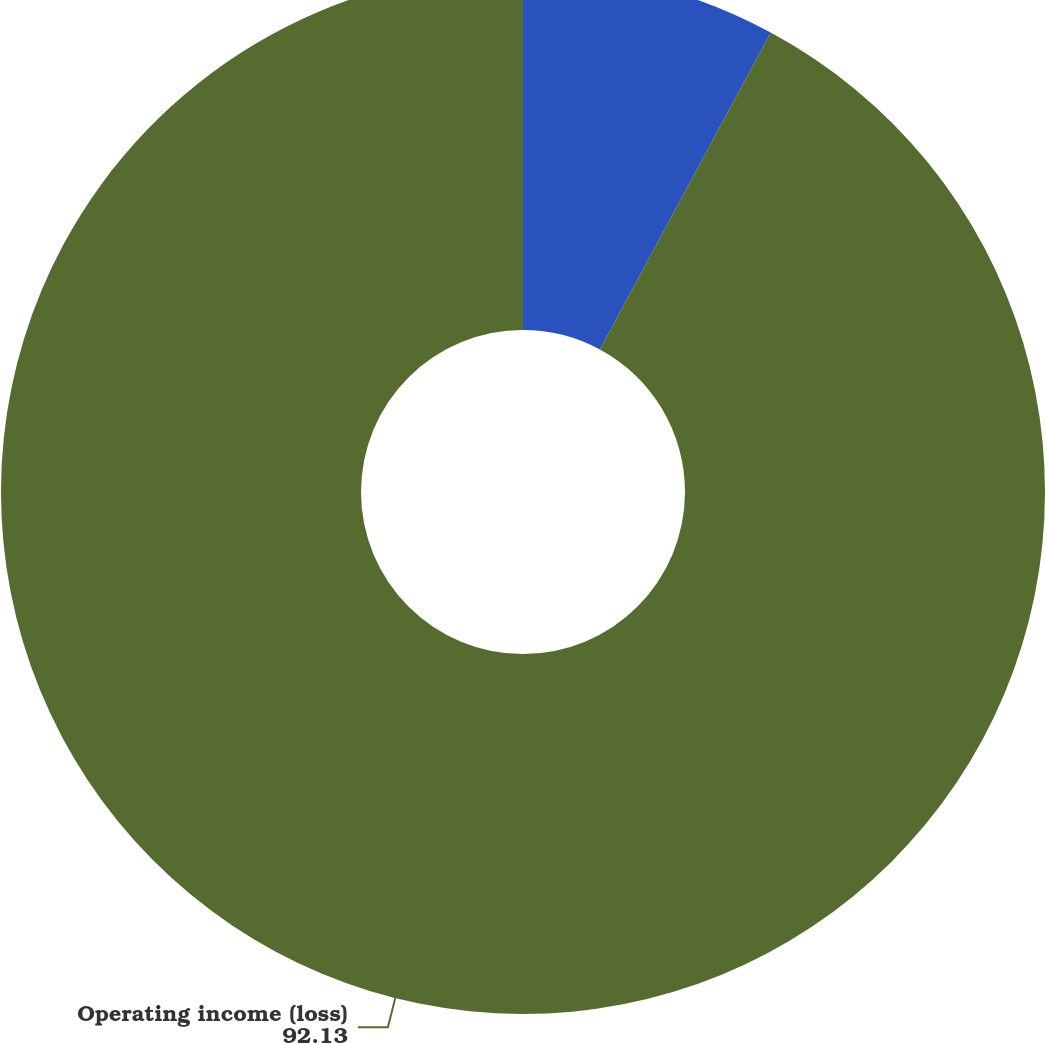Convert chart. <chart><loc_0><loc_0><loc_500><loc_500><pie_chart><fcel>Revenues<fcel>Operating income (loss)<nl><fcel>7.87%<fcel>92.13%<nl></chart> 